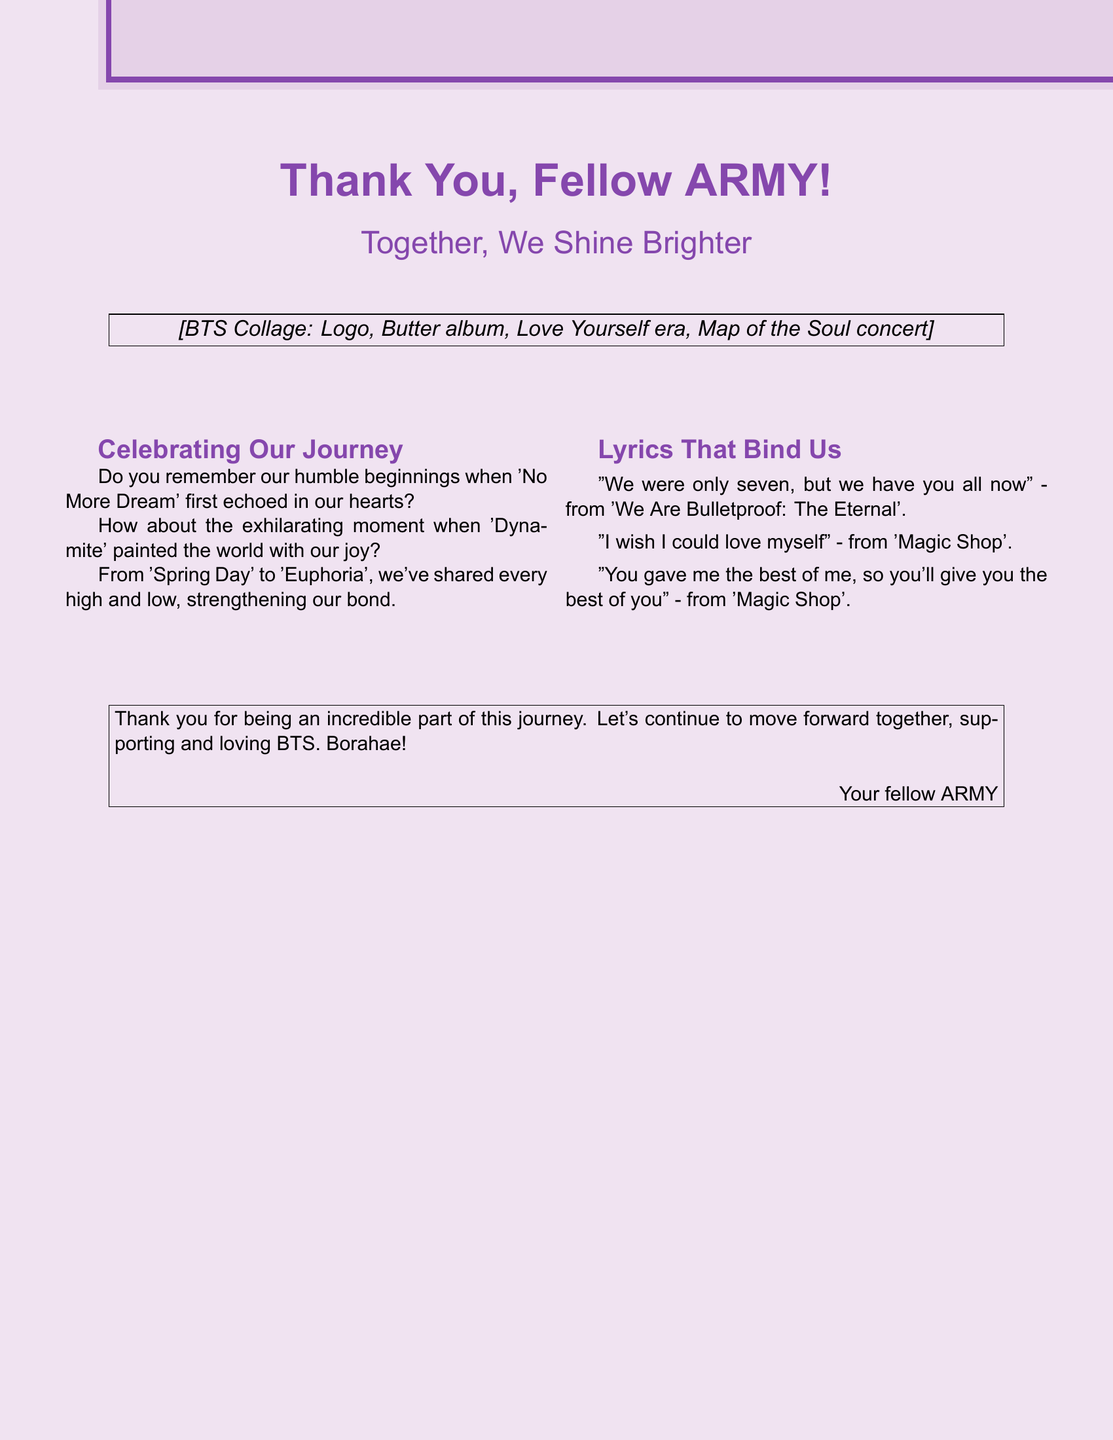What is the title of the card? The title of the card is prominently displayed at the top, capturing the overall theme of gratitude.
Answer: Thank You, Fellow ARMY! What color is the background of the card? The background color is applied to the entire card, creating a warm and inviting feel.
Answer: Lavender What is included in the collage mentioned in the card? The collage reflects BTS's significant work and moments, which is listed in the document.
Answer: Logo, Butter album, Love Yourself era, Map of the Soul concert Which song is quoted as "We were only seven, but we have you all now"? The quote comes from a specific BTS song that emphasizes unity and support among the fans.
Answer: We Are Bulletproof: The Eternal What does the card express gratitude for? The text in the card gives thanks for involvement in a shared journey, emphasizing camaraderie.
Answer: Being an incredible part of this journey Which era is mentioned alongside memories in the card? The card references a specific period in BTS's discography, highlighting significant songs.
Answer: Love Yourself era How many songs are quoted in the lyrics section? The document lists specific lyrics, indicating the amount referenced.
Answer: Three What does "Borahae" mean in the context of the card? This term is commonly used among BTS fans to express a specific sentiment toward each other and the group.
Answer: I purple you 